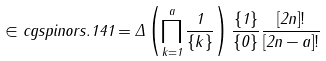<formula> <loc_0><loc_0><loc_500><loc_500>\in c g { s p i n o r s . 1 4 1 } = \Delta \left ( \prod _ { k = 1 } ^ { a } \frac { 1 } { \{ k \} } \right ) \frac { \{ 1 \} } { \{ 0 \} } \frac { [ 2 n ] ! } { [ 2 n - a ] ! }</formula> 